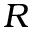<formula> <loc_0><loc_0><loc_500><loc_500>R</formula> 